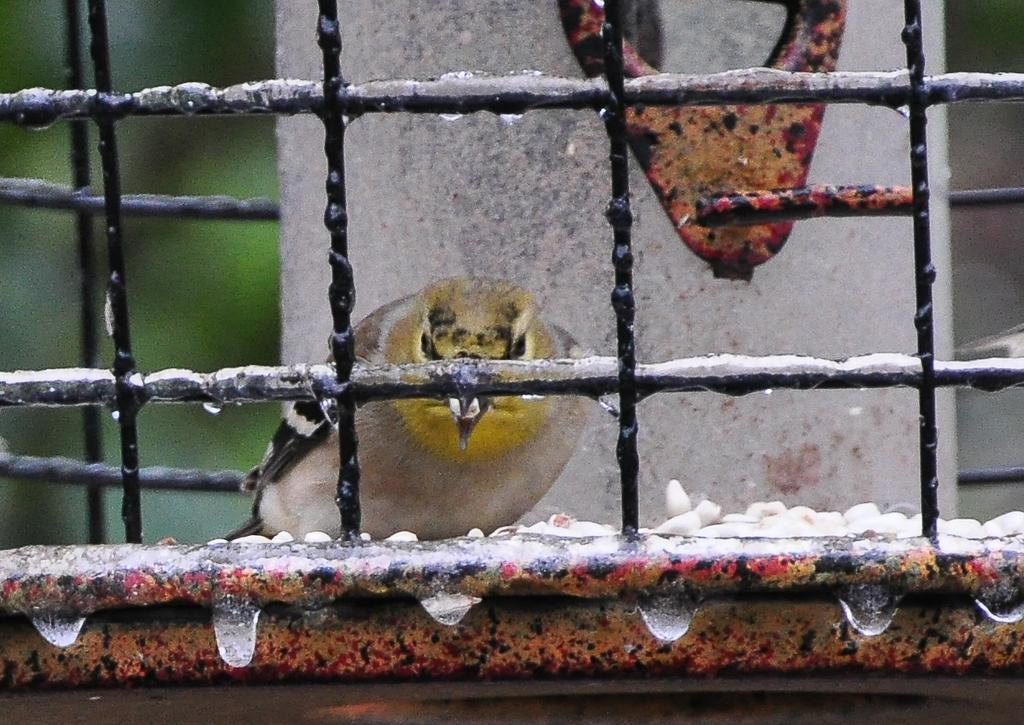What type of animal is present in the image? There is a bird in the image. Where is the bird located? The bird is inside a cage. Can you describe the environment around the cage? There are droplets of dew on the base of the cage. How many visitors are currently interacting with the bird in the image? There is no indication of any visitors interacting with the bird in the image. 